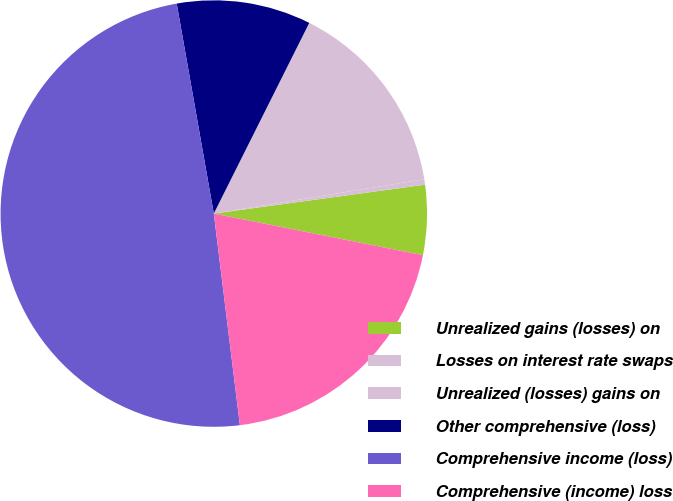<chart> <loc_0><loc_0><loc_500><loc_500><pie_chart><fcel>Unrealized gains (losses) on<fcel>Losses on interest rate swaps<fcel>Unrealized (losses) gains on<fcel>Other comprehensive (loss)<fcel>Comprehensive income (loss)<fcel>Comprehensive (income) loss<nl><fcel>5.29%<fcel>0.41%<fcel>15.04%<fcel>10.17%<fcel>49.17%<fcel>19.92%<nl></chart> 